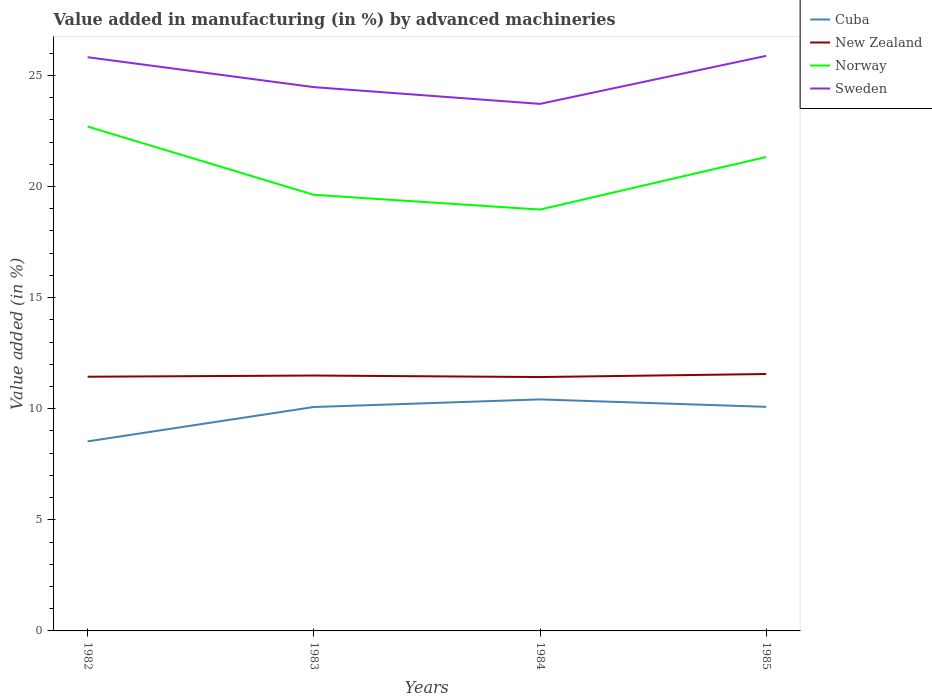Is the number of lines equal to the number of legend labels?
Keep it short and to the point. Yes. Across all years, what is the maximum percentage of value added in manufacturing by advanced machineries in Sweden?
Your response must be concise. 23.72. In which year was the percentage of value added in manufacturing by advanced machineries in Sweden maximum?
Keep it short and to the point. 1984. What is the total percentage of value added in manufacturing by advanced machineries in New Zealand in the graph?
Your response must be concise. -0.12. What is the difference between the highest and the second highest percentage of value added in manufacturing by advanced machineries in Norway?
Give a very brief answer. 3.74. What is the difference between the highest and the lowest percentage of value added in manufacturing by advanced machineries in Norway?
Provide a short and direct response. 2. Is the percentage of value added in manufacturing by advanced machineries in New Zealand strictly greater than the percentage of value added in manufacturing by advanced machineries in Norway over the years?
Offer a very short reply. Yes. Does the graph contain any zero values?
Provide a succinct answer. No. Where does the legend appear in the graph?
Your answer should be very brief. Top right. What is the title of the graph?
Your answer should be very brief. Value added in manufacturing (in %) by advanced machineries. What is the label or title of the X-axis?
Offer a terse response. Years. What is the label or title of the Y-axis?
Offer a terse response. Value added (in %). What is the Value added (in %) of Cuba in 1982?
Provide a succinct answer. 8.53. What is the Value added (in %) of New Zealand in 1982?
Offer a terse response. 11.44. What is the Value added (in %) of Norway in 1982?
Keep it short and to the point. 22.7. What is the Value added (in %) of Sweden in 1982?
Keep it short and to the point. 25.82. What is the Value added (in %) of Cuba in 1983?
Your response must be concise. 10.08. What is the Value added (in %) of New Zealand in 1983?
Offer a very short reply. 11.49. What is the Value added (in %) of Norway in 1983?
Offer a terse response. 19.63. What is the Value added (in %) of Sweden in 1983?
Offer a terse response. 24.47. What is the Value added (in %) of Cuba in 1984?
Make the answer very short. 10.42. What is the Value added (in %) of New Zealand in 1984?
Your response must be concise. 11.43. What is the Value added (in %) of Norway in 1984?
Your answer should be very brief. 18.97. What is the Value added (in %) of Sweden in 1984?
Offer a very short reply. 23.72. What is the Value added (in %) in Cuba in 1985?
Your answer should be compact. 10.09. What is the Value added (in %) in New Zealand in 1985?
Keep it short and to the point. 11.56. What is the Value added (in %) of Norway in 1985?
Ensure brevity in your answer.  21.33. What is the Value added (in %) of Sweden in 1985?
Make the answer very short. 25.88. Across all years, what is the maximum Value added (in %) of Cuba?
Keep it short and to the point. 10.42. Across all years, what is the maximum Value added (in %) in New Zealand?
Your answer should be very brief. 11.56. Across all years, what is the maximum Value added (in %) in Norway?
Give a very brief answer. 22.7. Across all years, what is the maximum Value added (in %) in Sweden?
Provide a short and direct response. 25.88. Across all years, what is the minimum Value added (in %) in Cuba?
Offer a very short reply. 8.53. Across all years, what is the minimum Value added (in %) in New Zealand?
Ensure brevity in your answer.  11.43. Across all years, what is the minimum Value added (in %) of Norway?
Keep it short and to the point. 18.97. Across all years, what is the minimum Value added (in %) in Sweden?
Give a very brief answer. 23.72. What is the total Value added (in %) in Cuba in the graph?
Offer a very short reply. 39.11. What is the total Value added (in %) in New Zealand in the graph?
Offer a terse response. 45.93. What is the total Value added (in %) of Norway in the graph?
Your response must be concise. 82.62. What is the total Value added (in %) of Sweden in the graph?
Offer a terse response. 99.9. What is the difference between the Value added (in %) of Cuba in 1982 and that in 1983?
Ensure brevity in your answer.  -1.55. What is the difference between the Value added (in %) in New Zealand in 1982 and that in 1983?
Provide a succinct answer. -0.05. What is the difference between the Value added (in %) in Norway in 1982 and that in 1983?
Give a very brief answer. 3.07. What is the difference between the Value added (in %) of Sweden in 1982 and that in 1983?
Keep it short and to the point. 1.35. What is the difference between the Value added (in %) of Cuba in 1982 and that in 1984?
Provide a succinct answer. -1.89. What is the difference between the Value added (in %) of New Zealand in 1982 and that in 1984?
Your answer should be compact. 0.01. What is the difference between the Value added (in %) in Norway in 1982 and that in 1984?
Your answer should be compact. 3.74. What is the difference between the Value added (in %) of Sweden in 1982 and that in 1984?
Your answer should be very brief. 2.1. What is the difference between the Value added (in %) in Cuba in 1982 and that in 1985?
Make the answer very short. -1.55. What is the difference between the Value added (in %) in New Zealand in 1982 and that in 1985?
Ensure brevity in your answer.  -0.12. What is the difference between the Value added (in %) of Norway in 1982 and that in 1985?
Offer a terse response. 1.37. What is the difference between the Value added (in %) in Sweden in 1982 and that in 1985?
Your answer should be very brief. -0.06. What is the difference between the Value added (in %) in Cuba in 1983 and that in 1984?
Offer a terse response. -0.34. What is the difference between the Value added (in %) of New Zealand in 1983 and that in 1984?
Offer a terse response. 0.07. What is the difference between the Value added (in %) of Norway in 1983 and that in 1984?
Your answer should be compact. 0.66. What is the difference between the Value added (in %) of Sweden in 1983 and that in 1984?
Offer a terse response. 0.75. What is the difference between the Value added (in %) in Cuba in 1983 and that in 1985?
Make the answer very short. -0.01. What is the difference between the Value added (in %) of New Zealand in 1983 and that in 1985?
Provide a short and direct response. -0.07. What is the difference between the Value added (in %) of Norway in 1983 and that in 1985?
Your answer should be compact. -1.7. What is the difference between the Value added (in %) in Sweden in 1983 and that in 1985?
Offer a terse response. -1.41. What is the difference between the Value added (in %) in Cuba in 1984 and that in 1985?
Provide a short and direct response. 0.33. What is the difference between the Value added (in %) of New Zealand in 1984 and that in 1985?
Provide a short and direct response. -0.14. What is the difference between the Value added (in %) in Norway in 1984 and that in 1985?
Your response must be concise. -2.36. What is the difference between the Value added (in %) of Sweden in 1984 and that in 1985?
Make the answer very short. -2.16. What is the difference between the Value added (in %) of Cuba in 1982 and the Value added (in %) of New Zealand in 1983?
Provide a short and direct response. -2.96. What is the difference between the Value added (in %) of Cuba in 1982 and the Value added (in %) of Norway in 1983?
Your answer should be compact. -11.1. What is the difference between the Value added (in %) in Cuba in 1982 and the Value added (in %) in Sweden in 1983?
Give a very brief answer. -15.94. What is the difference between the Value added (in %) in New Zealand in 1982 and the Value added (in %) in Norway in 1983?
Keep it short and to the point. -8.19. What is the difference between the Value added (in %) in New Zealand in 1982 and the Value added (in %) in Sweden in 1983?
Keep it short and to the point. -13.03. What is the difference between the Value added (in %) of Norway in 1982 and the Value added (in %) of Sweden in 1983?
Your response must be concise. -1.77. What is the difference between the Value added (in %) of Cuba in 1982 and the Value added (in %) of New Zealand in 1984?
Your answer should be compact. -2.9. What is the difference between the Value added (in %) in Cuba in 1982 and the Value added (in %) in Norway in 1984?
Provide a short and direct response. -10.43. What is the difference between the Value added (in %) in Cuba in 1982 and the Value added (in %) in Sweden in 1984?
Provide a short and direct response. -15.19. What is the difference between the Value added (in %) of New Zealand in 1982 and the Value added (in %) of Norway in 1984?
Provide a succinct answer. -7.52. What is the difference between the Value added (in %) in New Zealand in 1982 and the Value added (in %) in Sweden in 1984?
Ensure brevity in your answer.  -12.28. What is the difference between the Value added (in %) of Norway in 1982 and the Value added (in %) of Sweden in 1984?
Provide a short and direct response. -1.02. What is the difference between the Value added (in %) of Cuba in 1982 and the Value added (in %) of New Zealand in 1985?
Your answer should be very brief. -3.03. What is the difference between the Value added (in %) in Cuba in 1982 and the Value added (in %) in Norway in 1985?
Keep it short and to the point. -12.8. What is the difference between the Value added (in %) of Cuba in 1982 and the Value added (in %) of Sweden in 1985?
Make the answer very short. -17.35. What is the difference between the Value added (in %) in New Zealand in 1982 and the Value added (in %) in Norway in 1985?
Make the answer very short. -9.89. What is the difference between the Value added (in %) of New Zealand in 1982 and the Value added (in %) of Sweden in 1985?
Provide a short and direct response. -14.44. What is the difference between the Value added (in %) in Norway in 1982 and the Value added (in %) in Sweden in 1985?
Provide a succinct answer. -3.18. What is the difference between the Value added (in %) of Cuba in 1983 and the Value added (in %) of New Zealand in 1984?
Ensure brevity in your answer.  -1.35. What is the difference between the Value added (in %) of Cuba in 1983 and the Value added (in %) of Norway in 1984?
Make the answer very short. -8.89. What is the difference between the Value added (in %) in Cuba in 1983 and the Value added (in %) in Sweden in 1984?
Your answer should be very brief. -13.64. What is the difference between the Value added (in %) in New Zealand in 1983 and the Value added (in %) in Norway in 1984?
Make the answer very short. -7.47. What is the difference between the Value added (in %) in New Zealand in 1983 and the Value added (in %) in Sweden in 1984?
Offer a very short reply. -12.23. What is the difference between the Value added (in %) of Norway in 1983 and the Value added (in %) of Sweden in 1984?
Your answer should be compact. -4.09. What is the difference between the Value added (in %) of Cuba in 1983 and the Value added (in %) of New Zealand in 1985?
Give a very brief answer. -1.49. What is the difference between the Value added (in %) in Cuba in 1983 and the Value added (in %) in Norway in 1985?
Give a very brief answer. -11.25. What is the difference between the Value added (in %) in Cuba in 1983 and the Value added (in %) in Sweden in 1985?
Provide a short and direct response. -15.81. What is the difference between the Value added (in %) of New Zealand in 1983 and the Value added (in %) of Norway in 1985?
Give a very brief answer. -9.83. What is the difference between the Value added (in %) of New Zealand in 1983 and the Value added (in %) of Sweden in 1985?
Ensure brevity in your answer.  -14.39. What is the difference between the Value added (in %) of Norway in 1983 and the Value added (in %) of Sweden in 1985?
Provide a short and direct response. -6.25. What is the difference between the Value added (in %) of Cuba in 1984 and the Value added (in %) of New Zealand in 1985?
Your answer should be compact. -1.14. What is the difference between the Value added (in %) of Cuba in 1984 and the Value added (in %) of Norway in 1985?
Make the answer very short. -10.91. What is the difference between the Value added (in %) in Cuba in 1984 and the Value added (in %) in Sweden in 1985?
Offer a very short reply. -15.46. What is the difference between the Value added (in %) of New Zealand in 1984 and the Value added (in %) of Norway in 1985?
Offer a very short reply. -9.9. What is the difference between the Value added (in %) of New Zealand in 1984 and the Value added (in %) of Sweden in 1985?
Your answer should be very brief. -14.46. What is the difference between the Value added (in %) in Norway in 1984 and the Value added (in %) in Sweden in 1985?
Your answer should be compact. -6.92. What is the average Value added (in %) in Cuba per year?
Your answer should be compact. 9.78. What is the average Value added (in %) in New Zealand per year?
Your response must be concise. 11.48. What is the average Value added (in %) of Norway per year?
Offer a terse response. 20.66. What is the average Value added (in %) in Sweden per year?
Your answer should be compact. 24.98. In the year 1982, what is the difference between the Value added (in %) of Cuba and Value added (in %) of New Zealand?
Give a very brief answer. -2.91. In the year 1982, what is the difference between the Value added (in %) in Cuba and Value added (in %) in Norway?
Offer a very short reply. -14.17. In the year 1982, what is the difference between the Value added (in %) in Cuba and Value added (in %) in Sweden?
Provide a succinct answer. -17.29. In the year 1982, what is the difference between the Value added (in %) of New Zealand and Value added (in %) of Norway?
Make the answer very short. -11.26. In the year 1982, what is the difference between the Value added (in %) of New Zealand and Value added (in %) of Sweden?
Give a very brief answer. -14.38. In the year 1982, what is the difference between the Value added (in %) of Norway and Value added (in %) of Sweden?
Provide a succinct answer. -3.12. In the year 1983, what is the difference between the Value added (in %) in Cuba and Value added (in %) in New Zealand?
Offer a very short reply. -1.42. In the year 1983, what is the difference between the Value added (in %) in Cuba and Value added (in %) in Norway?
Keep it short and to the point. -9.55. In the year 1983, what is the difference between the Value added (in %) in Cuba and Value added (in %) in Sweden?
Offer a terse response. -14.4. In the year 1983, what is the difference between the Value added (in %) of New Zealand and Value added (in %) of Norway?
Keep it short and to the point. -8.13. In the year 1983, what is the difference between the Value added (in %) of New Zealand and Value added (in %) of Sweden?
Your response must be concise. -12.98. In the year 1983, what is the difference between the Value added (in %) in Norway and Value added (in %) in Sweden?
Keep it short and to the point. -4.85. In the year 1984, what is the difference between the Value added (in %) of Cuba and Value added (in %) of New Zealand?
Provide a short and direct response. -1.01. In the year 1984, what is the difference between the Value added (in %) of Cuba and Value added (in %) of Norway?
Your answer should be compact. -8.54. In the year 1984, what is the difference between the Value added (in %) in Cuba and Value added (in %) in Sweden?
Your response must be concise. -13.3. In the year 1984, what is the difference between the Value added (in %) of New Zealand and Value added (in %) of Norway?
Offer a very short reply. -7.54. In the year 1984, what is the difference between the Value added (in %) of New Zealand and Value added (in %) of Sweden?
Offer a very short reply. -12.29. In the year 1984, what is the difference between the Value added (in %) in Norway and Value added (in %) in Sweden?
Give a very brief answer. -4.76. In the year 1985, what is the difference between the Value added (in %) in Cuba and Value added (in %) in New Zealand?
Provide a short and direct response. -1.48. In the year 1985, what is the difference between the Value added (in %) of Cuba and Value added (in %) of Norway?
Offer a very short reply. -11.24. In the year 1985, what is the difference between the Value added (in %) in Cuba and Value added (in %) in Sweden?
Your answer should be very brief. -15.8. In the year 1985, what is the difference between the Value added (in %) of New Zealand and Value added (in %) of Norway?
Provide a succinct answer. -9.77. In the year 1985, what is the difference between the Value added (in %) in New Zealand and Value added (in %) in Sweden?
Provide a succinct answer. -14.32. In the year 1985, what is the difference between the Value added (in %) in Norway and Value added (in %) in Sweden?
Offer a terse response. -4.55. What is the ratio of the Value added (in %) of Cuba in 1982 to that in 1983?
Your answer should be compact. 0.85. What is the ratio of the Value added (in %) of Norway in 1982 to that in 1983?
Offer a terse response. 1.16. What is the ratio of the Value added (in %) in Sweden in 1982 to that in 1983?
Make the answer very short. 1.05. What is the ratio of the Value added (in %) of Cuba in 1982 to that in 1984?
Your answer should be very brief. 0.82. What is the ratio of the Value added (in %) of Norway in 1982 to that in 1984?
Offer a very short reply. 1.2. What is the ratio of the Value added (in %) in Sweden in 1982 to that in 1984?
Provide a succinct answer. 1.09. What is the ratio of the Value added (in %) in Cuba in 1982 to that in 1985?
Your answer should be very brief. 0.85. What is the ratio of the Value added (in %) of Norway in 1982 to that in 1985?
Keep it short and to the point. 1.06. What is the ratio of the Value added (in %) of Sweden in 1982 to that in 1985?
Offer a very short reply. 1. What is the ratio of the Value added (in %) in Cuba in 1983 to that in 1984?
Ensure brevity in your answer.  0.97. What is the ratio of the Value added (in %) of New Zealand in 1983 to that in 1984?
Your answer should be compact. 1.01. What is the ratio of the Value added (in %) of Norway in 1983 to that in 1984?
Make the answer very short. 1.03. What is the ratio of the Value added (in %) of Sweden in 1983 to that in 1984?
Your response must be concise. 1.03. What is the ratio of the Value added (in %) of Cuba in 1983 to that in 1985?
Keep it short and to the point. 1. What is the ratio of the Value added (in %) in Norway in 1983 to that in 1985?
Provide a succinct answer. 0.92. What is the ratio of the Value added (in %) in Sweden in 1983 to that in 1985?
Your answer should be compact. 0.95. What is the ratio of the Value added (in %) of Cuba in 1984 to that in 1985?
Your response must be concise. 1.03. What is the ratio of the Value added (in %) of New Zealand in 1984 to that in 1985?
Your answer should be very brief. 0.99. What is the ratio of the Value added (in %) of Norway in 1984 to that in 1985?
Your answer should be very brief. 0.89. What is the ratio of the Value added (in %) in Sweden in 1984 to that in 1985?
Keep it short and to the point. 0.92. What is the difference between the highest and the second highest Value added (in %) of Cuba?
Provide a succinct answer. 0.33. What is the difference between the highest and the second highest Value added (in %) of New Zealand?
Give a very brief answer. 0.07. What is the difference between the highest and the second highest Value added (in %) in Norway?
Your response must be concise. 1.37. What is the difference between the highest and the second highest Value added (in %) of Sweden?
Give a very brief answer. 0.06. What is the difference between the highest and the lowest Value added (in %) in Cuba?
Offer a very short reply. 1.89. What is the difference between the highest and the lowest Value added (in %) in New Zealand?
Offer a terse response. 0.14. What is the difference between the highest and the lowest Value added (in %) in Norway?
Make the answer very short. 3.74. What is the difference between the highest and the lowest Value added (in %) of Sweden?
Your answer should be compact. 2.16. 